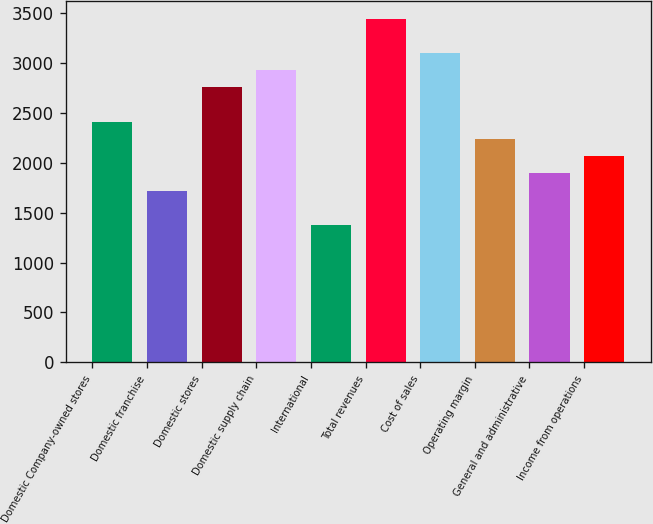Convert chart. <chart><loc_0><loc_0><loc_500><loc_500><bar_chart><fcel>Domestic Company-owned stores<fcel>Domestic franchise<fcel>Domestic stores<fcel>Domestic supply chain<fcel>International<fcel>Total revenues<fcel>Cost of sales<fcel>Operating margin<fcel>General and administrative<fcel>Income from operations<nl><fcel>2407.89<fcel>1720.09<fcel>2751.79<fcel>2923.74<fcel>1376.19<fcel>3439.59<fcel>3095.69<fcel>2235.94<fcel>1892.04<fcel>2063.99<nl></chart> 